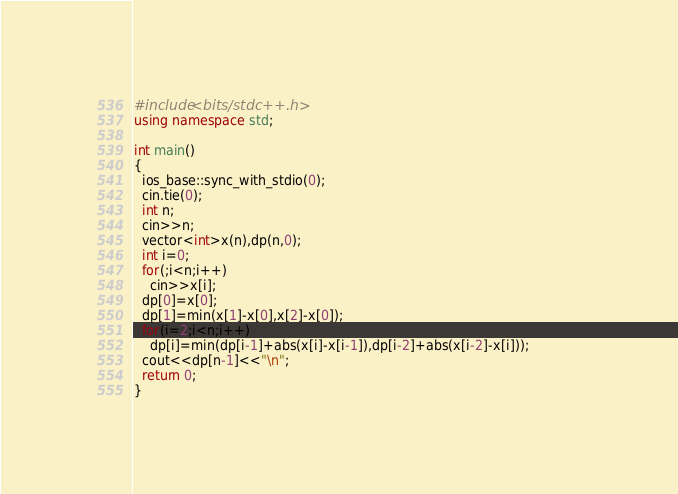Convert code to text. <code><loc_0><loc_0><loc_500><loc_500><_C++_>#include<bits/stdc++.h>
using namespace std;

int main()
{
  ios_base::sync_with_stdio(0);
  cin.tie(0);
  int n;
  cin>>n;
  vector<int>x(n),dp(n,0);
  int i=0;
  for(;i<n;i++)
    cin>>x[i];
  dp[0]=x[0];
  dp[1]=min(x[1]-x[0],x[2]-x[0]);
  for(i=2;i<n;i++)
    dp[i]=min(dp[i-1]+abs(x[i]-x[i-1]),dp[i-2]+abs(x[i-2]-x[i]));             
  cout<<dp[n-1]<<"\n";
  return 0;
}</code> 